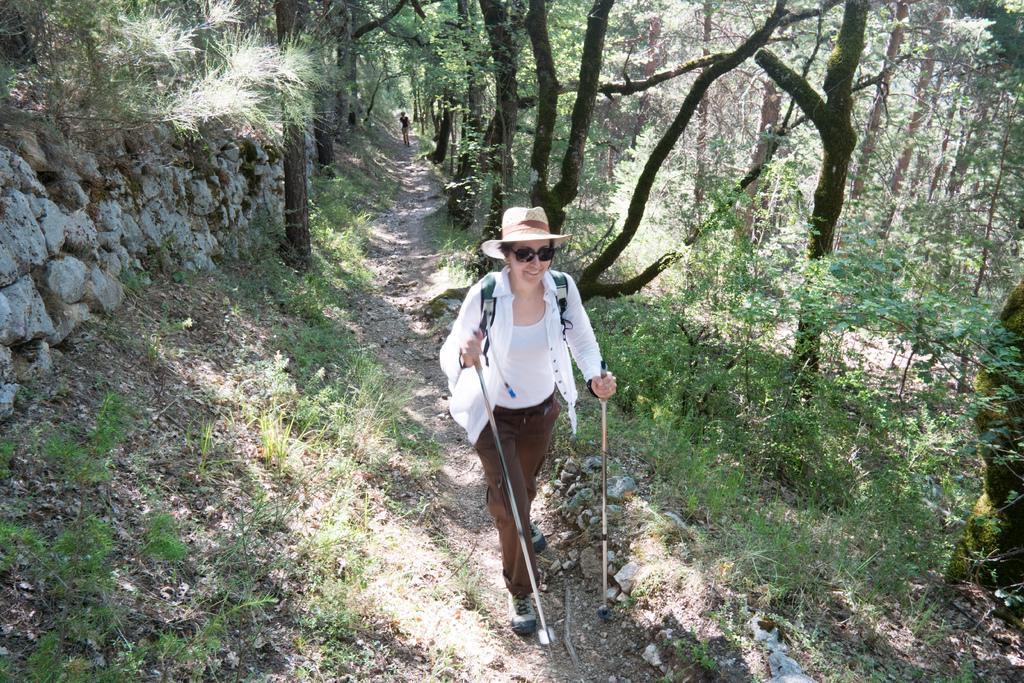In one or two sentences, can you explain what this image depicts? In this image there is a woman walking, she is wearing a bag, she is wearing a hat, she is wearing goggles, she is holding an object, there are trees towards the top of the image, there are trees towards the right of the image, there is a rock wall towards the left of the image. 